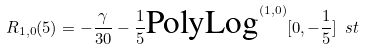Convert formula to latex. <formula><loc_0><loc_0><loc_500><loc_500>R _ { 1 , 0 } ( 5 ) = - \frac { \gamma } { 3 0 } - \frac { 1 } { 5 } \text {PolyLog} ^ { ( 1 , 0 ) } [ 0 , - \frac { 1 } { 5 } ] \ s t</formula> 